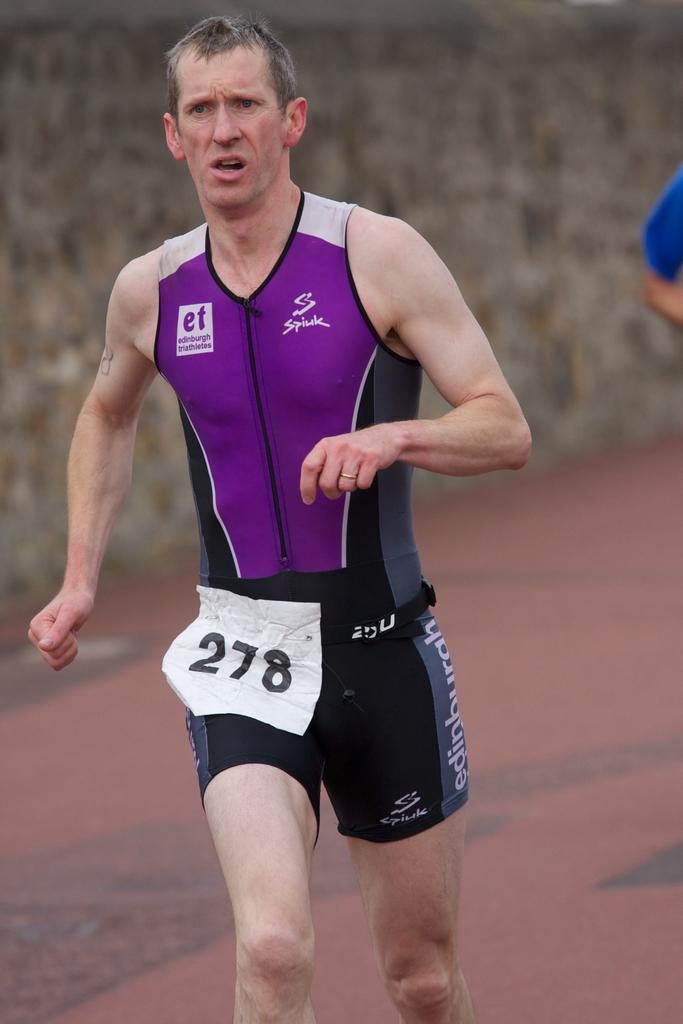<image>
Give a short and clear explanation of the subsequent image. 1 men running on the track with the numbers 278 